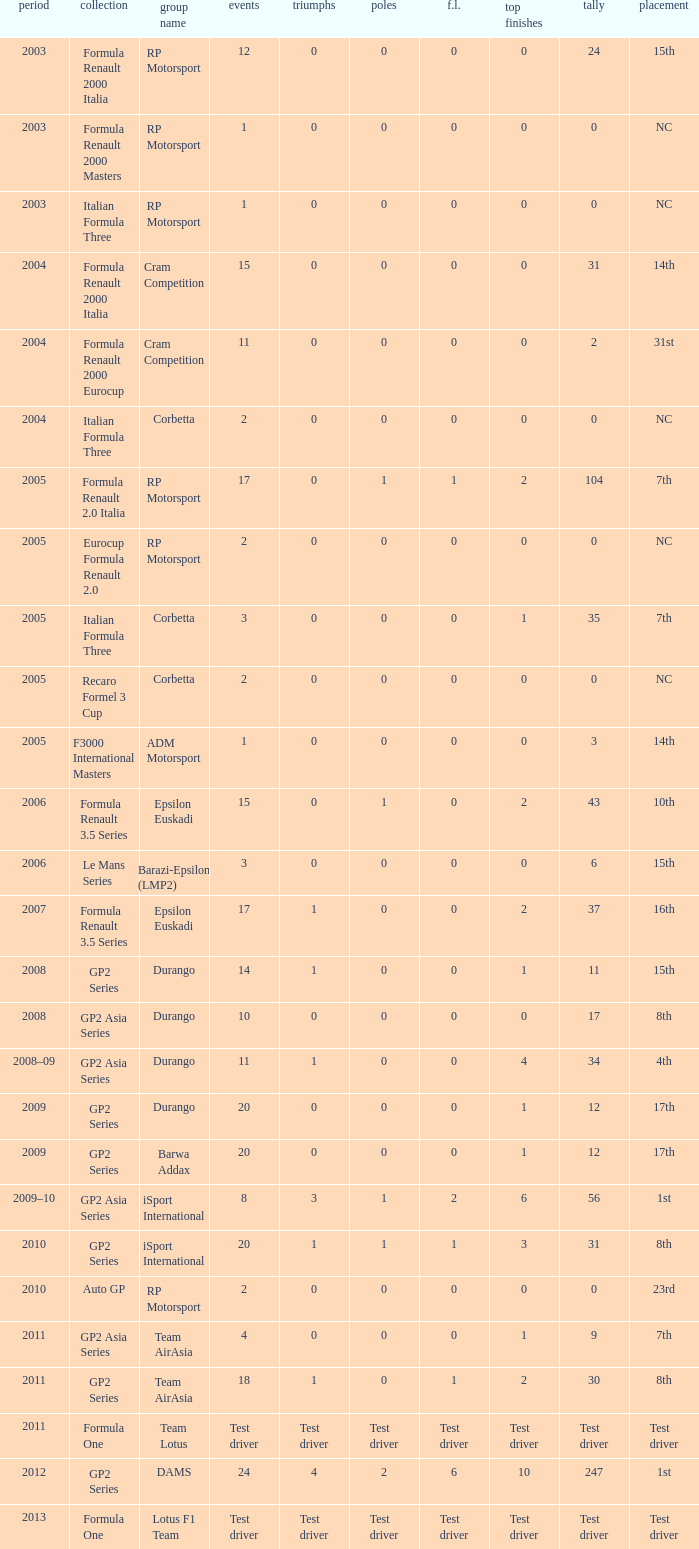What races have gp2 series, 0 F.L. and a 17th position? 20, 20. 